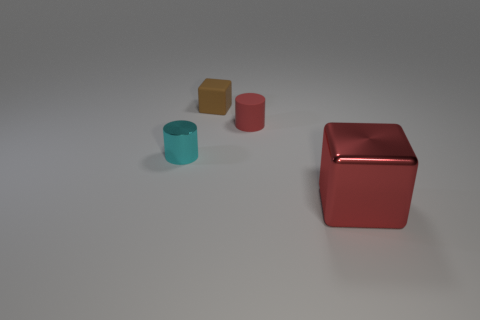Add 2 tiny cyan objects. How many objects exist? 6 Add 2 tiny brown cubes. How many tiny brown cubes are left? 3 Add 4 large gray metal cylinders. How many large gray metal cylinders exist? 4 Subtract 0 gray blocks. How many objects are left? 4 Subtract all purple metal blocks. Subtract all large cubes. How many objects are left? 3 